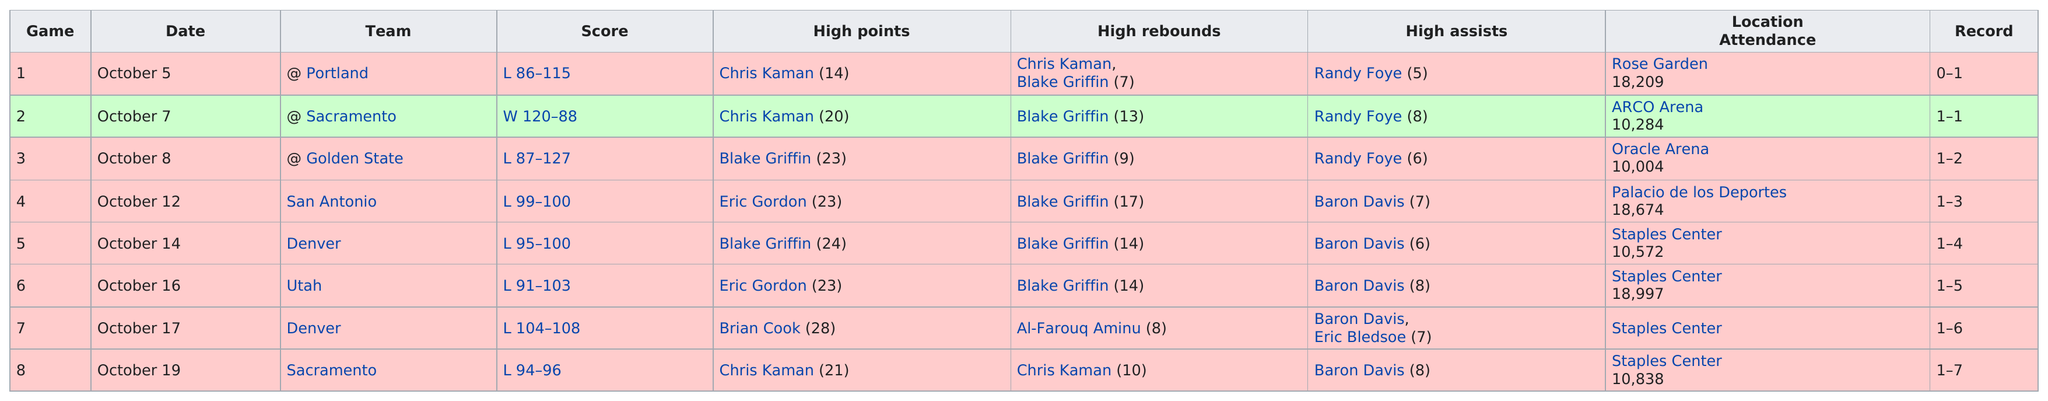Indicate a few pertinent items in this graphic. Before the Clippers finally won a game in the pre-season, they faced 1 loss. During the 2010 pre-season, the Los Angeles Clippers played after Utah. The opponent they played against was Denver. The first preseason game was held at the Rose Garden. In the 2010 pre-season game of the Clippers, a minimum of 5 high assists was obtained. Chris Kaman scored the highest points in three games. 